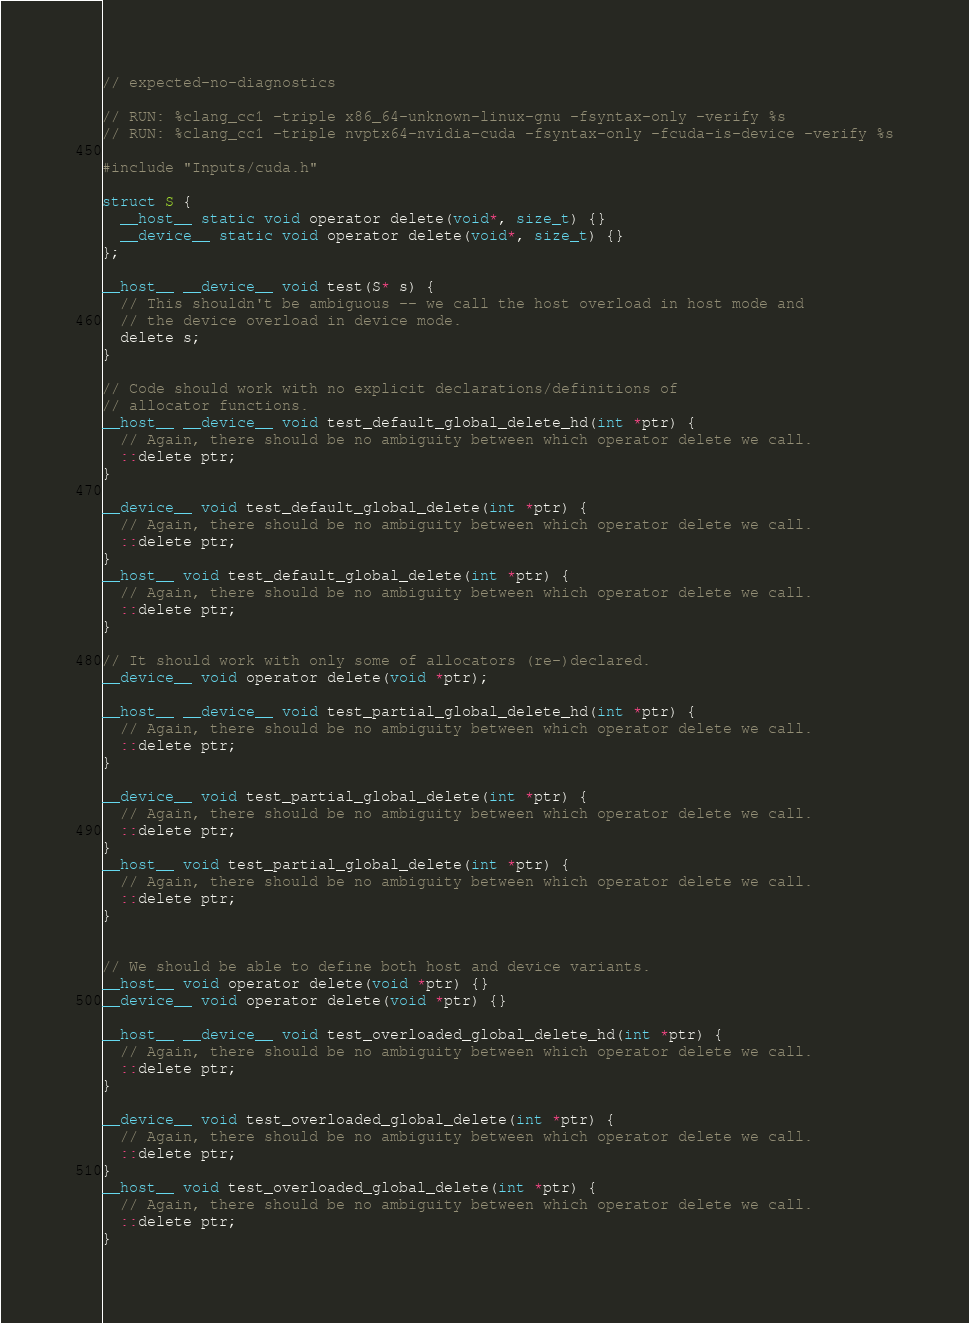Convert code to text. <code><loc_0><loc_0><loc_500><loc_500><_Cuda_>// expected-no-diagnostics

// RUN: %clang_cc1 -triple x86_64-unknown-linux-gnu -fsyntax-only -verify %s
// RUN: %clang_cc1 -triple nvptx64-nvidia-cuda -fsyntax-only -fcuda-is-device -verify %s

#include "Inputs/cuda.h"

struct S {
  __host__ static void operator delete(void*, size_t) {}
  __device__ static void operator delete(void*, size_t) {}
};

__host__ __device__ void test(S* s) {
  // This shouldn't be ambiguous -- we call the host overload in host mode and
  // the device overload in device mode.
  delete s;
}

// Code should work with no explicit declarations/definitions of
// allocator functions.
__host__ __device__ void test_default_global_delete_hd(int *ptr) {
  // Again, there should be no ambiguity between which operator delete we call.
  ::delete ptr;
}

__device__ void test_default_global_delete(int *ptr) {
  // Again, there should be no ambiguity between which operator delete we call.
  ::delete ptr;
}
__host__ void test_default_global_delete(int *ptr) {
  // Again, there should be no ambiguity between which operator delete we call.
  ::delete ptr;
}

// It should work with only some of allocators (re-)declared.
__device__ void operator delete(void *ptr);

__host__ __device__ void test_partial_global_delete_hd(int *ptr) {
  // Again, there should be no ambiguity between which operator delete we call.
  ::delete ptr;
}

__device__ void test_partial_global_delete(int *ptr) {
  // Again, there should be no ambiguity between which operator delete we call.
  ::delete ptr;
}
__host__ void test_partial_global_delete(int *ptr) {
  // Again, there should be no ambiguity between which operator delete we call.
  ::delete ptr;
}


// We should be able to define both host and device variants.
__host__ void operator delete(void *ptr) {}
__device__ void operator delete(void *ptr) {}

__host__ __device__ void test_overloaded_global_delete_hd(int *ptr) {
  // Again, there should be no ambiguity between which operator delete we call.
  ::delete ptr;
}

__device__ void test_overloaded_global_delete(int *ptr) {
  // Again, there should be no ambiguity between which operator delete we call.
  ::delete ptr;
}
__host__ void test_overloaded_global_delete(int *ptr) {
  // Again, there should be no ambiguity between which operator delete we call.
  ::delete ptr;
}
</code> 